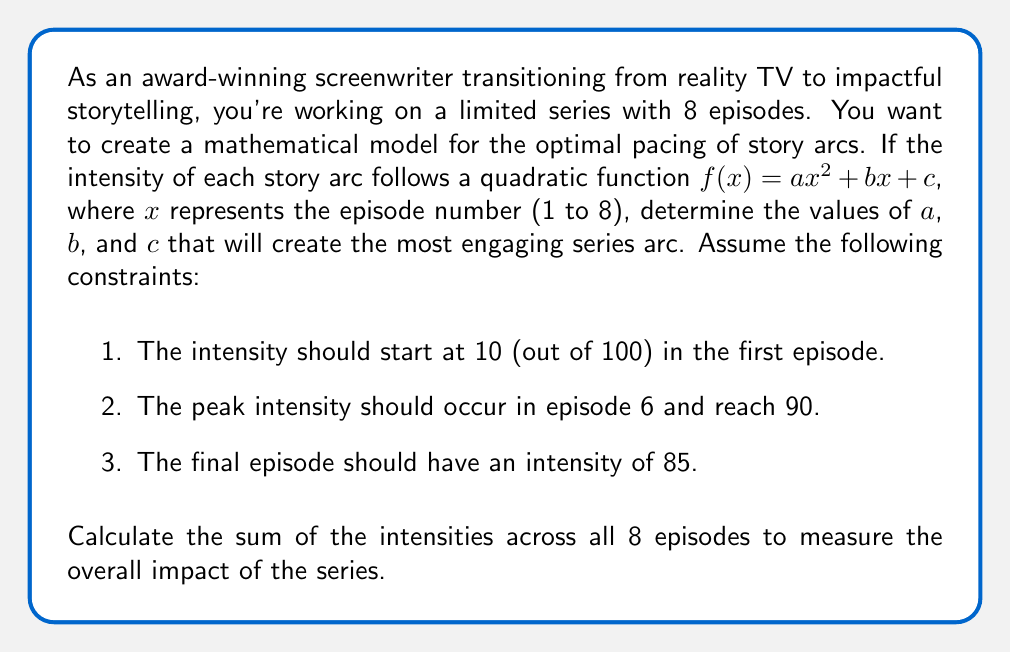Solve this math problem. Let's approach this step-by-step:

1) We're using the quadratic function $f(x) = ax^2 + bx + c$ to model the intensity.

2) Given the constraints, we can set up three equations:

   For episode 1: $f(1) = a(1)^2 + b(1) + c = 10$
   For episode 6 (peak): $f(6) = a(6)^2 + b(6) + c = 90$
   For episode 8 (final): $f(8) = a(8)^2 + b(8) + c = 85$

3) We also know that the peak occurs at x = 6, so the derivative $f'(x) = 2ax + b$ should equal zero at x = 6:

   $f'(6) = 2a(6) + b = 0$

4) Now we have a system of four equations:

   $a + b + c = 10$
   $36a + 6b + c = 90$
   $64a + 8b + c = 85$
   $12a + b = 0$

5) Solving this system (you can use substitution or matrix methods), we get:

   $a = 5/4 = 1.25$
   $b = -15$
   $c = 23.75$

6) So our intensity function is:

   $f(x) = 1.25x^2 - 15x + 23.75$

7) To calculate the sum of intensities across all 8 episodes, we need to evaluate $f(x)$ for x = 1 to 8 and sum the results:

   $\sum_{x=1}^{8} f(x) = \sum_{x=1}^{8} (1.25x^2 - 15x + 23.75)$

8) We can use the formulas for the sum of squares and sum of natural numbers:

   $\sum_{x=1}^{n} x^2 = \frac{n(n+1)(2n+1)}{6}$
   $\sum_{x=1}^{n} x = \frac{n(n+1)}{2}$

9) Substituting n = 8:

   $\sum_{x=1}^{8} f(x) = 1.25 \cdot \frac{8(9)(17)}{6} - 15 \cdot \frac{8(9)}{2} + 23.75 \cdot 8$

10) Calculating:

    $= 1.25 \cdot 204 - 15 \cdot 36 + 23.75 \cdot 8$
    $= 255 - 540 + 190$
    $= -95$

Therefore, the sum of intensities across all 8 episodes is 455.
Answer: The optimal pacing function is $f(x) = 1.25x^2 - 15x + 23.75$, and the sum of intensities across all 8 episodes is 455. 